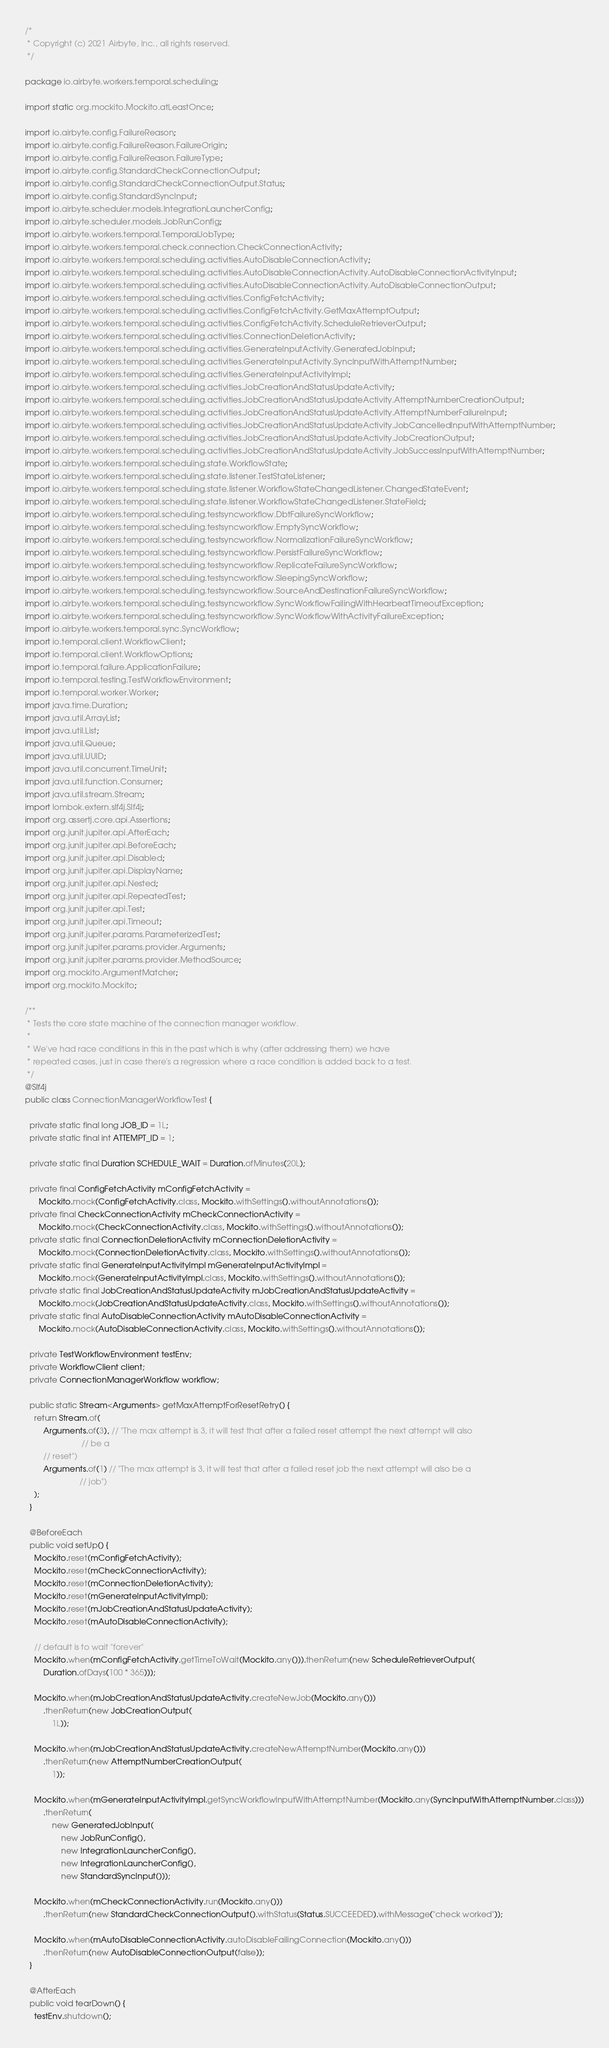Convert code to text. <code><loc_0><loc_0><loc_500><loc_500><_Java_>/*
 * Copyright (c) 2021 Airbyte, Inc., all rights reserved.
 */

package io.airbyte.workers.temporal.scheduling;

import static org.mockito.Mockito.atLeastOnce;

import io.airbyte.config.FailureReason;
import io.airbyte.config.FailureReason.FailureOrigin;
import io.airbyte.config.FailureReason.FailureType;
import io.airbyte.config.StandardCheckConnectionOutput;
import io.airbyte.config.StandardCheckConnectionOutput.Status;
import io.airbyte.config.StandardSyncInput;
import io.airbyte.scheduler.models.IntegrationLauncherConfig;
import io.airbyte.scheduler.models.JobRunConfig;
import io.airbyte.workers.temporal.TemporalJobType;
import io.airbyte.workers.temporal.check.connection.CheckConnectionActivity;
import io.airbyte.workers.temporal.scheduling.activities.AutoDisableConnectionActivity;
import io.airbyte.workers.temporal.scheduling.activities.AutoDisableConnectionActivity.AutoDisableConnectionActivityInput;
import io.airbyte.workers.temporal.scheduling.activities.AutoDisableConnectionActivity.AutoDisableConnectionOutput;
import io.airbyte.workers.temporal.scheduling.activities.ConfigFetchActivity;
import io.airbyte.workers.temporal.scheduling.activities.ConfigFetchActivity.GetMaxAttemptOutput;
import io.airbyte.workers.temporal.scheduling.activities.ConfigFetchActivity.ScheduleRetrieverOutput;
import io.airbyte.workers.temporal.scheduling.activities.ConnectionDeletionActivity;
import io.airbyte.workers.temporal.scheduling.activities.GenerateInputActivity.GeneratedJobInput;
import io.airbyte.workers.temporal.scheduling.activities.GenerateInputActivity.SyncInputWithAttemptNumber;
import io.airbyte.workers.temporal.scheduling.activities.GenerateInputActivityImpl;
import io.airbyte.workers.temporal.scheduling.activities.JobCreationAndStatusUpdateActivity;
import io.airbyte.workers.temporal.scheduling.activities.JobCreationAndStatusUpdateActivity.AttemptNumberCreationOutput;
import io.airbyte.workers.temporal.scheduling.activities.JobCreationAndStatusUpdateActivity.AttemptNumberFailureInput;
import io.airbyte.workers.temporal.scheduling.activities.JobCreationAndStatusUpdateActivity.JobCancelledInputWithAttemptNumber;
import io.airbyte.workers.temporal.scheduling.activities.JobCreationAndStatusUpdateActivity.JobCreationOutput;
import io.airbyte.workers.temporal.scheduling.activities.JobCreationAndStatusUpdateActivity.JobSuccessInputWithAttemptNumber;
import io.airbyte.workers.temporal.scheduling.state.WorkflowState;
import io.airbyte.workers.temporal.scheduling.state.listener.TestStateListener;
import io.airbyte.workers.temporal.scheduling.state.listener.WorkflowStateChangedListener.ChangedStateEvent;
import io.airbyte.workers.temporal.scheduling.state.listener.WorkflowStateChangedListener.StateField;
import io.airbyte.workers.temporal.scheduling.testsyncworkflow.DbtFailureSyncWorkflow;
import io.airbyte.workers.temporal.scheduling.testsyncworkflow.EmptySyncWorkflow;
import io.airbyte.workers.temporal.scheduling.testsyncworkflow.NormalizationFailureSyncWorkflow;
import io.airbyte.workers.temporal.scheduling.testsyncworkflow.PersistFailureSyncWorkflow;
import io.airbyte.workers.temporal.scheduling.testsyncworkflow.ReplicateFailureSyncWorkflow;
import io.airbyte.workers.temporal.scheduling.testsyncworkflow.SleepingSyncWorkflow;
import io.airbyte.workers.temporal.scheduling.testsyncworkflow.SourceAndDestinationFailureSyncWorkflow;
import io.airbyte.workers.temporal.scheduling.testsyncworkflow.SyncWorkflowFailingWithHearbeatTimeoutException;
import io.airbyte.workers.temporal.scheduling.testsyncworkflow.SyncWorkflowWithActivityFailureException;
import io.airbyte.workers.temporal.sync.SyncWorkflow;
import io.temporal.client.WorkflowClient;
import io.temporal.client.WorkflowOptions;
import io.temporal.failure.ApplicationFailure;
import io.temporal.testing.TestWorkflowEnvironment;
import io.temporal.worker.Worker;
import java.time.Duration;
import java.util.ArrayList;
import java.util.List;
import java.util.Queue;
import java.util.UUID;
import java.util.concurrent.TimeUnit;
import java.util.function.Consumer;
import java.util.stream.Stream;
import lombok.extern.slf4j.Slf4j;
import org.assertj.core.api.Assertions;
import org.junit.jupiter.api.AfterEach;
import org.junit.jupiter.api.BeforeEach;
import org.junit.jupiter.api.Disabled;
import org.junit.jupiter.api.DisplayName;
import org.junit.jupiter.api.Nested;
import org.junit.jupiter.api.RepeatedTest;
import org.junit.jupiter.api.Test;
import org.junit.jupiter.api.Timeout;
import org.junit.jupiter.params.ParameterizedTest;
import org.junit.jupiter.params.provider.Arguments;
import org.junit.jupiter.params.provider.MethodSource;
import org.mockito.ArgumentMatcher;
import org.mockito.Mockito;

/**
 * Tests the core state machine of the connection manager workflow.
 *
 * We've had race conditions in this in the past which is why (after addressing them) we have
 * repeated cases, just in case there's a regression where a race condition is added back to a test.
 */
@Slf4j
public class ConnectionManagerWorkflowTest {

  private static final long JOB_ID = 1L;
  private static final int ATTEMPT_ID = 1;

  private static final Duration SCHEDULE_WAIT = Duration.ofMinutes(20L);

  private final ConfigFetchActivity mConfigFetchActivity =
      Mockito.mock(ConfigFetchActivity.class, Mockito.withSettings().withoutAnnotations());
  private final CheckConnectionActivity mCheckConnectionActivity =
      Mockito.mock(CheckConnectionActivity.class, Mockito.withSettings().withoutAnnotations());
  private static final ConnectionDeletionActivity mConnectionDeletionActivity =
      Mockito.mock(ConnectionDeletionActivity.class, Mockito.withSettings().withoutAnnotations());
  private static final GenerateInputActivityImpl mGenerateInputActivityImpl =
      Mockito.mock(GenerateInputActivityImpl.class, Mockito.withSettings().withoutAnnotations());
  private static final JobCreationAndStatusUpdateActivity mJobCreationAndStatusUpdateActivity =
      Mockito.mock(JobCreationAndStatusUpdateActivity.class, Mockito.withSettings().withoutAnnotations());
  private static final AutoDisableConnectionActivity mAutoDisableConnectionActivity =
      Mockito.mock(AutoDisableConnectionActivity.class, Mockito.withSettings().withoutAnnotations());

  private TestWorkflowEnvironment testEnv;
  private WorkflowClient client;
  private ConnectionManagerWorkflow workflow;

  public static Stream<Arguments> getMaxAttemptForResetRetry() {
    return Stream.of(
        Arguments.of(3), // "The max attempt is 3, it will test that after a failed reset attempt the next attempt will also
                         // be a
        // reset")
        Arguments.of(1) // "The max attempt is 3, it will test that after a failed reset job the next attempt will also be a
                        // job")
    );
  }

  @BeforeEach
  public void setUp() {
    Mockito.reset(mConfigFetchActivity);
    Mockito.reset(mCheckConnectionActivity);
    Mockito.reset(mConnectionDeletionActivity);
    Mockito.reset(mGenerateInputActivityImpl);
    Mockito.reset(mJobCreationAndStatusUpdateActivity);
    Mockito.reset(mAutoDisableConnectionActivity);

    // default is to wait "forever"
    Mockito.when(mConfigFetchActivity.getTimeToWait(Mockito.any())).thenReturn(new ScheduleRetrieverOutput(
        Duration.ofDays(100 * 365)));

    Mockito.when(mJobCreationAndStatusUpdateActivity.createNewJob(Mockito.any()))
        .thenReturn(new JobCreationOutput(
            1L));

    Mockito.when(mJobCreationAndStatusUpdateActivity.createNewAttemptNumber(Mockito.any()))
        .thenReturn(new AttemptNumberCreationOutput(
            1));

    Mockito.when(mGenerateInputActivityImpl.getSyncWorkflowInputWithAttemptNumber(Mockito.any(SyncInputWithAttemptNumber.class)))
        .thenReturn(
            new GeneratedJobInput(
                new JobRunConfig(),
                new IntegrationLauncherConfig(),
                new IntegrationLauncherConfig(),
                new StandardSyncInput()));

    Mockito.when(mCheckConnectionActivity.run(Mockito.any()))
        .thenReturn(new StandardCheckConnectionOutput().withStatus(Status.SUCCEEDED).withMessage("check worked"));

    Mockito.when(mAutoDisableConnectionActivity.autoDisableFailingConnection(Mockito.any()))
        .thenReturn(new AutoDisableConnectionOutput(false));
  }

  @AfterEach
  public void tearDown() {
    testEnv.shutdown();</code> 